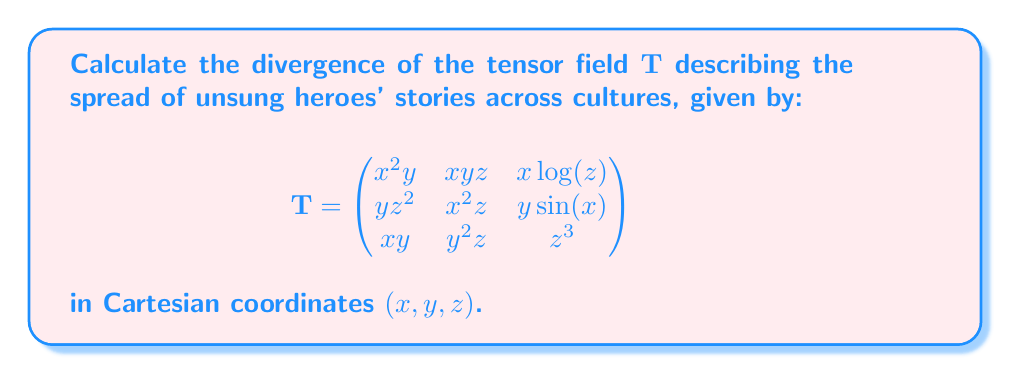Show me your answer to this math problem. To calculate the divergence of a tensor field, we need to sum the partial derivatives of the diagonal elements with respect to their corresponding variables:

1) First, we identify the diagonal elements:
   $T_{11} = x^2y$
   $T_{22} = x^2z$
   $T_{33} = z^3$

2) Now, we calculate the partial derivatives:

   $\frac{\partial T_{11}}{\partial x} = \frac{\partial}{\partial x}(x^2y) = 2xy$

   $\frac{\partial T_{22}}{\partial y} = \frac{\partial}{\partial y}(x^2z) = 0$

   $\frac{\partial T_{33}}{\partial z} = \frac{\partial}{\partial z}(z^3) = 3z^2$

3) The divergence is the sum of these partial derivatives:

   $\text{div}(\mathbf{T}) = \frac{\partial T_{11}}{\partial x} + \frac{\partial T_{22}}{\partial y} + \frac{\partial T_{33}}{\partial z}$

   $\text{div}(\mathbf{T}) = 2xy + 0 + 3z^2$

4) Simplifying:

   $\text{div}(\mathbf{T}) = 2xy + 3z^2$

This result represents the rate at which the stories of unsung heroes spread across cultures, with respect to the given coordinate system.
Answer: $2xy + 3z^2$ 